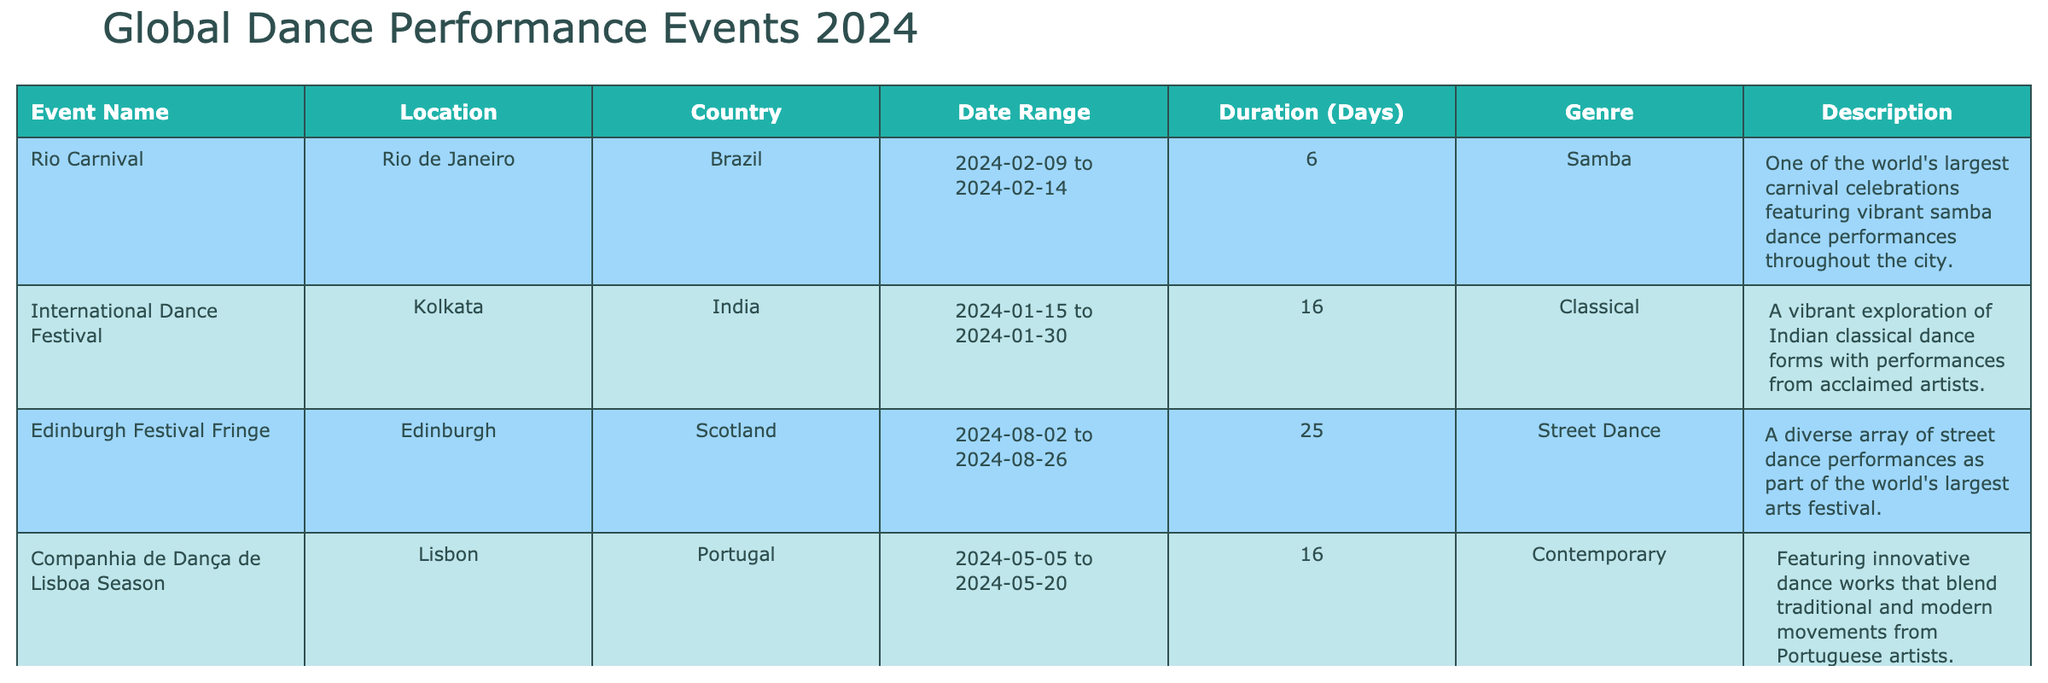What is the duration of the Rio Carnival in days? The duration of the Rio Carnival can be found by looking at the "Duration (Days)" column next to the "Rio Carnival" event. It shows that the event lasts for 6 days, from February 9 to February 14, 2024.
Answer: 6 Which two events take place in May? By examining the "Start Date" column, I can identify that there are two events listed for May: the "Companhia de Dança de Lisboa Season" which starts on May 5 and the "Rio Carnival" which does not. Therefore, the event that takes place in May is only the "Companhia de Dança de Lisboa Season".
Answer: Companhia de Dança de Lisboa Season Is the International Dance Festival classified as a contemporary genre? Looking at the "Genre" column next to the International Dance Festival, it is categorized as "Classical," not "Contemporary." Thus, the statement is false.
Answer: No How many days does the Edinburgh Festival Fringe last? The "Duration (Days)" column next to the "Edinburgh Festival Fringe" indicates that it lasts for 25 days, from August 2 to August 26, 2024.
Answer: 25 What are the genres of events held in England? Checking the "Country" and "Genre" columns, the only event listed in England is the "Glastonbury Festival," which is classified under "Various." Therefore, the genre for events in England is "Various."
Answer: Various Which event is the longest in duration and how many days does it last? By comparing the "Duration (Days)" column for each event, the "Glastonbury Festival" has the longest duration of 5 days, as it is listed to take place from June 26 to June 30, 2024.
Answer: 5 How many events are held in the first half of 2024? By dividing the events based on their start dates in the "Start Date" column, there are four events taking place between January and June (International Dance Festival, Rio Carnival, Glastonbury Festival, and Companhia de Dança de Lisboa Season).
Answer: 4 Is there a street dance performance during the Edinburgh Festival Fringe? Yes, the "Edinburgh Festival Fringe" is explicitly categorized under "Street Dance" in the "Genre" column, confirming the presence of street dance performances.
Answer: Yes 